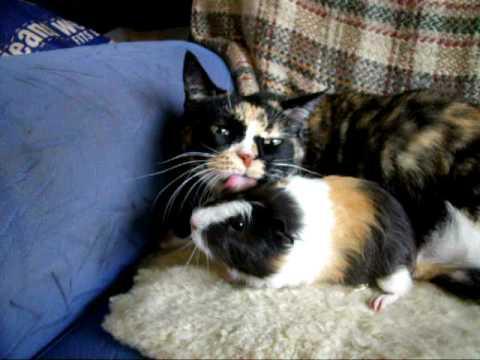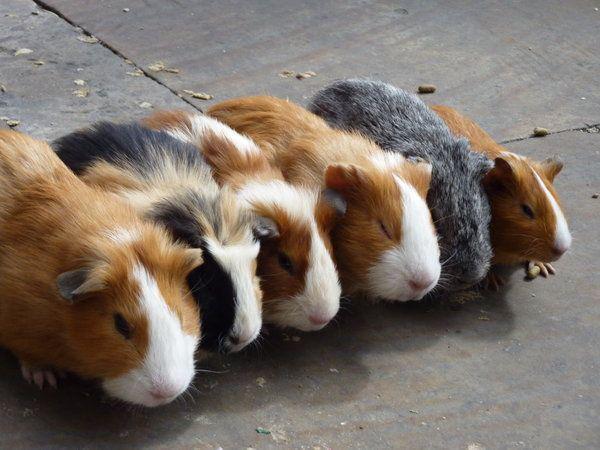The first image is the image on the left, the second image is the image on the right. Assess this claim about the two images: "There are three species of animals.". Correct or not? Answer yes or no. No. The first image is the image on the left, the second image is the image on the right. Analyze the images presented: Is the assertion "Each image shows a guinea pig posed next to a different kind of pet, and one image shows a cat sleeping with its head against an awake guinea pig." valid? Answer yes or no. No. 